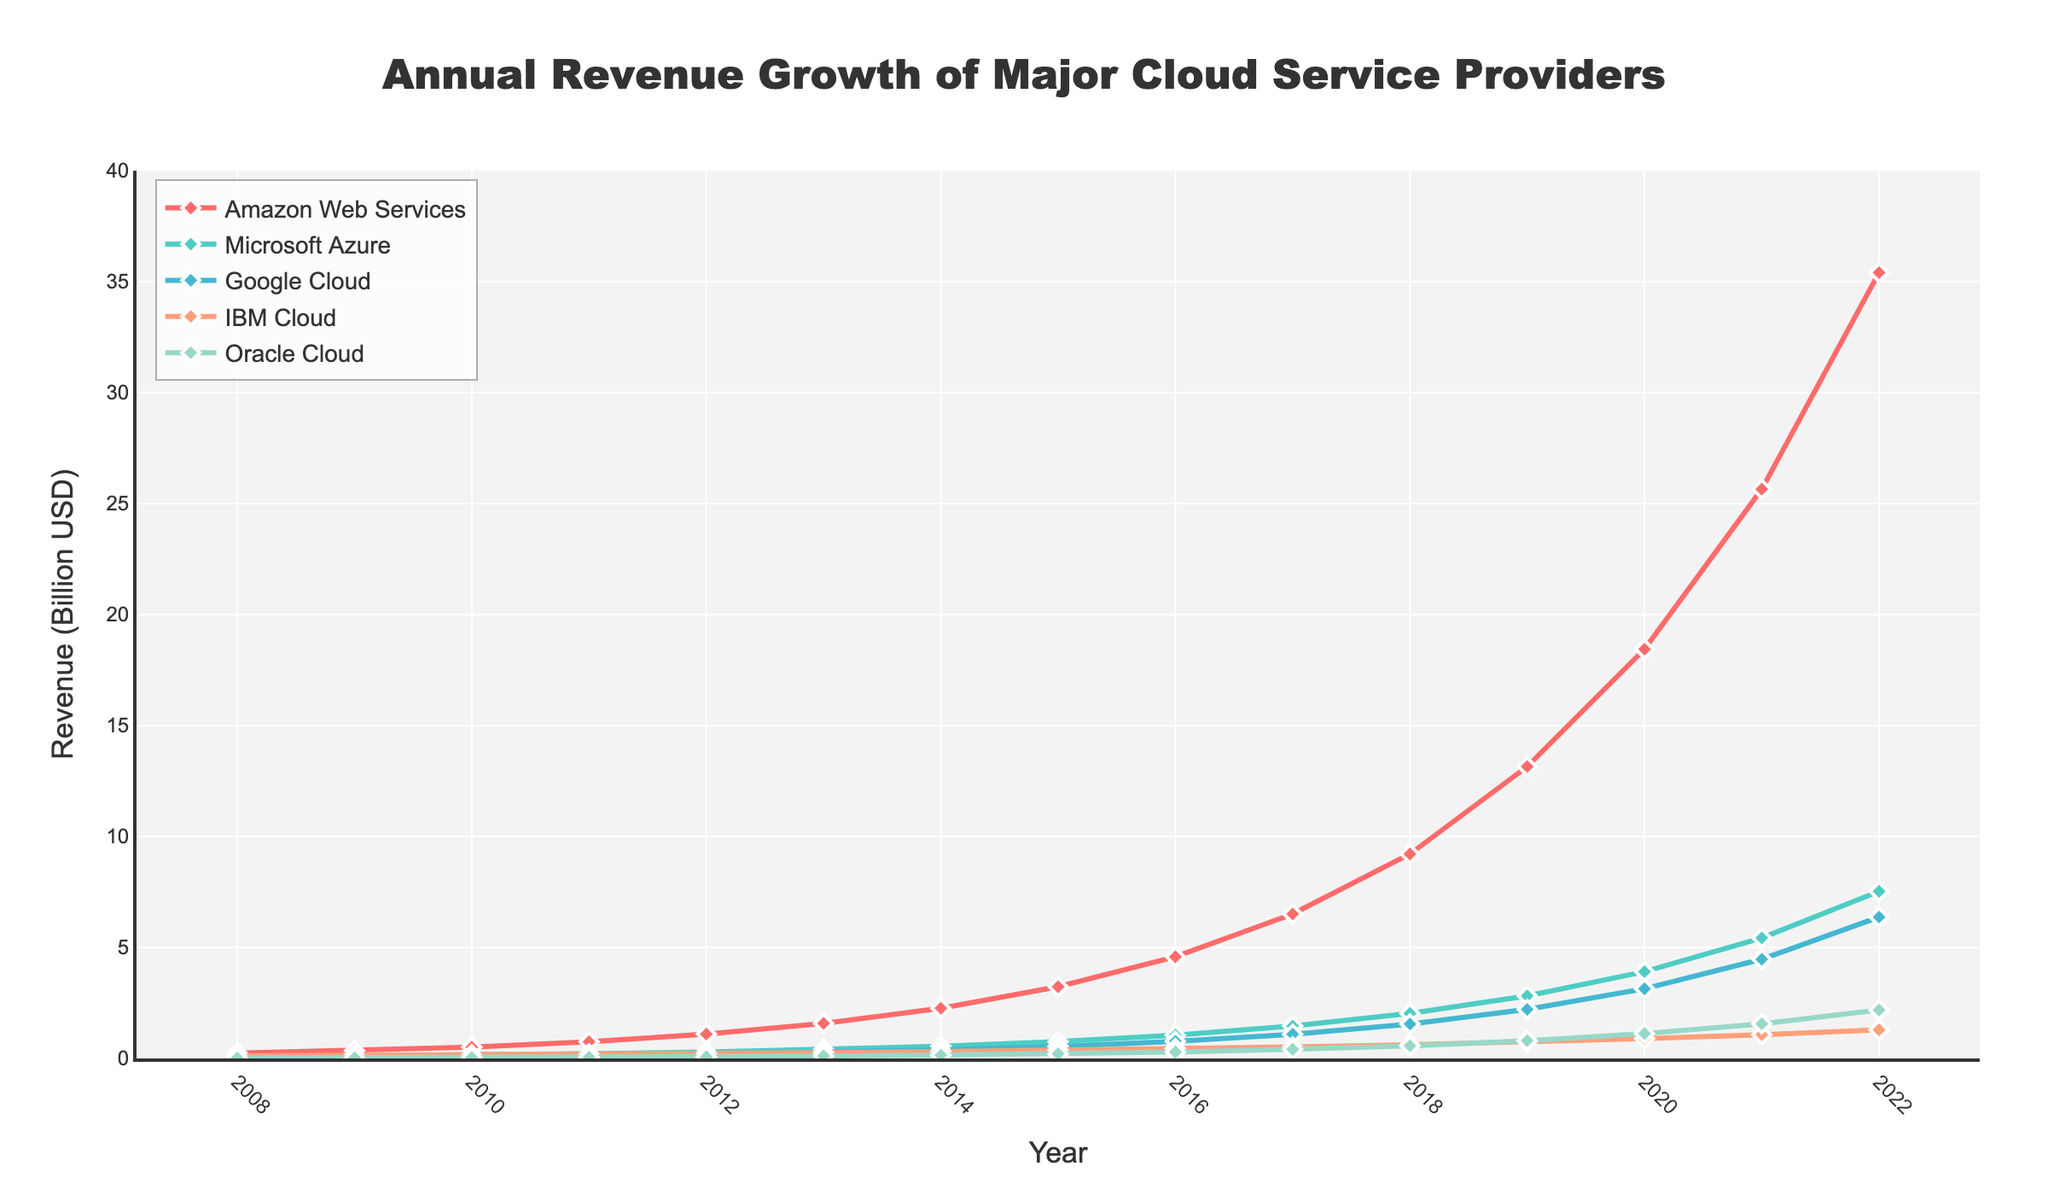What year did Amazon Web Services surpass 10 billion USD in revenue? Look for the point on the line representing Amazon Web Services where the y-value exceeds 10. This happens around 2018.
Answer: 2018 Compare the revenue growth of Google Cloud and Oracle Cloud in 2020. Check the values for Google Cloud and Oracle Cloud in 2020. Google Cloud has a revenue of 3.14 billion, and Oracle Cloud has 1.12 billion. Google Cloud's revenue is greater in 2020.
Answer: Google Cloud Which cloud service provider had the fastest growth between 2015 and 2016? Calculate the revenue differences between 2015 and 2016 for each provider. AWS: 4.58-3.23=1.35, Azure: 1.05-0.76=0.29, Google Cloud: 0.77-0.54=0.23, IBM Cloud: 0.44-0.37=0.07, and Oracle Cloud: 0.29-0.21=0.08. AWS had the largest growth.
Answer: Amazon Web Services How much did IBM Cloud's revenue increase from 2008 to 2022? Subtract IBM Cloud's revenue in 2008 from its revenue in 2022. The values are 1.29 - 0.12 = 1.17 billion USD.
Answer: 1.17 billion USD What is the difference in revenue between Amazon Web Services and Microsoft Azure in 2022? Subtract Microsoft Azure's revenue in 2022 from Amazon Web Services' revenue in 2022. The values are 35.41 - 7.53 = 27.88 billion USD.
Answer: 27.88 billion USD Which provider had the smallest revenue in 2013? Check the revenue values for all providers in 2013. Google Cloud: 0.27, Oracle Cloud: 0.11, IBM Cloud: 0.26, AWS: 1.58, and Azure: 0.40. Oracle Cloud had the smallest revenue.
Answer: Oracle Cloud How many providers had a revenue increase from 2019 to 2022? Compare the revenue of each provider between 2019 and 2022. AWS: 13.15 to 35.41, Azure: 2.82 to 7.53, Google Cloud: 2.21 to 6.37, IBM Cloud: 0.74 to 1.29, Oracle Cloud: 0.80 to 2.18. All five providers had an increase.
Answer: 5 What was the total revenue of all cloud providers in 2021? Sum the revenue values of all providers in 2021: 25.65 (AWS) + 5.43 (Azure) + 4.47 (Google Cloud) + 1.07 (IBM Cloud) + 1.56 (Oracle Cloud) = 38.18 billion USD.
Answer: 38.18 billion USD Which year marked the start of a rapid increase in revenue for Amazon Web Services? Identify the year where the slope of the AWS line steepens significantly. AWS' revenue shows a rapid increase starting from 2015.
Answer: 2015 Between which consecutive years did Oracle Cloud experience its highest growth? Find the largest increase in Oracle Cloud revenues between consecutive years. The values are highest between 2021 (1.56) and 2022 (2.18), giving a growth of 0.62.
Answer: 2021 and 2022 